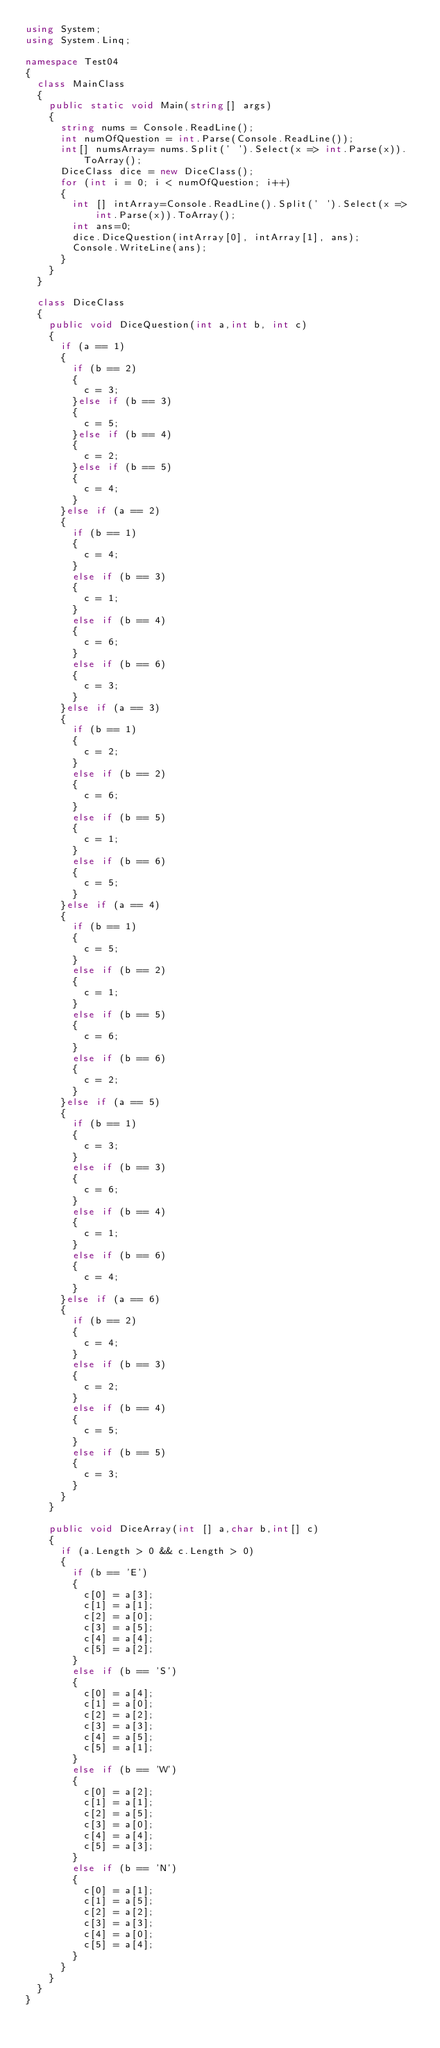<code> <loc_0><loc_0><loc_500><loc_500><_C#_>using System;
using System.Linq;

namespace Test04
{
	class MainClass
	{
		public static void Main(string[] args)
		{
			string nums = Console.ReadLine();
			int numOfQuestion = int.Parse(Console.ReadLine());
			int[] numsArray= nums.Split(' ').Select(x => int.Parse(x)).ToArray();
			DiceClass dice = new DiceClass();
			for (int i = 0; i < numOfQuestion; i++)
			{
				int [] intArray=Console.ReadLine().Split(' ').Select(x => int.Parse(x)).ToArray();
				int ans=0;
				dice.DiceQuestion(intArray[0], intArray[1], ans);
				Console.WriteLine(ans);
			}
		}
	}

	class DiceClass
	{
		public void DiceQuestion(int a,int b, int c)
		{
			if (a == 1)
			{ 
				if (b == 2)
				{
					c = 3;
				}else if (b == 3)
				{
					c = 5;
				}else if (b == 4)
				{
					c = 2;
				}else if (b == 5)
				{
					c = 4;
				}
			}else if (a == 2)
			{
				if (b == 1)
				{
					c = 4;
				}
				else if (b == 3)
				{
					c = 1;
				}
				else if (b == 4)
				{
					c = 6;
				}
				else if (b == 6)
				{
					c = 3;
				}
			}else if (a == 3)
			{
				if (b == 1)
				{
					c = 2;
				}
				else if (b == 2)
				{
					c = 6;
				}
				else if (b == 5)
				{
					c = 1;
				}
				else if (b == 6)
				{
					c = 5;
				}
			}else if (a == 4)
			{
				if (b == 1)
				{
					c = 5;
				}
				else if (b == 2)
				{
					c = 1;
				}
				else if (b == 5)
				{
					c = 6;
				}
				else if (b == 6)
				{
					c = 2;
				}
			}else if (a == 5)
			{
				if (b == 1)
				{
					c = 3;
				}
				else if (b == 3)
				{
					c = 6;
				}
				else if (b == 4)
				{
					c = 1;
				}
				else if (b == 6)
				{
					c = 4;
				}
			}else if (a == 6)
			{
				if (b == 2)
				{
					c = 4;
				}
				else if (b == 3)
				{
					c = 2;
				}
				else if (b == 4)
				{
					c = 5;
				}
				else if (b == 5)
				{
					c = 3;
				}
			}
		}

		public void DiceArray(int [] a,char b,int[] c)
		{
			if (a.Length > 0 && c.Length > 0)
			{
				if (b == 'E')
				{
					c[0] = a[3];
					c[1] = a[1];
					c[2] = a[0];
					c[3] = a[5];
					c[4] = a[4];
					c[5] = a[2];
				}
				else if (b == 'S')
				{
					c[0] = a[4];
					c[1] = a[0];
					c[2] = a[2];
					c[3] = a[3];
					c[4] = a[5];
					c[5] = a[1];
				}
				else if (b == 'W')
				{
					c[0] = a[2];
					c[1] = a[1];
					c[2] = a[5];
					c[3] = a[0];
					c[4] = a[4];
					c[5] = a[3];
				}
				else if (b == 'N')
				{
					c[0] = a[1];
					c[1] = a[5];
					c[2] = a[2];
					c[3] = a[3];
					c[4] = a[0];
					c[5] = a[4];
				}
			}
		}
	}
}</code> 